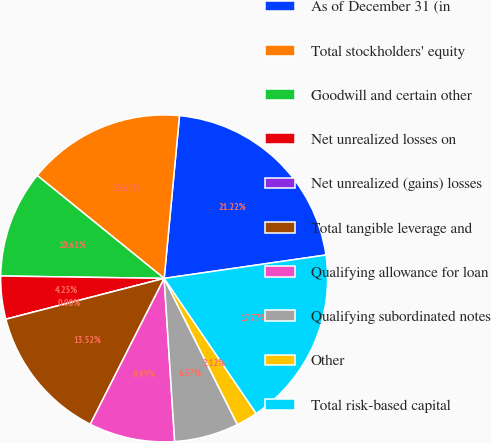<chart> <loc_0><loc_0><loc_500><loc_500><pie_chart><fcel>As of December 31 (in<fcel>Total stockholders' equity<fcel>Goodwill and certain other<fcel>Net unrealized losses on<fcel>Net unrealized (gains) losses<fcel>Total tangible leverage and<fcel>Qualifying allowance for loan<fcel>Qualifying subordinated notes<fcel>Other<fcel>Total risk-based capital<nl><fcel>21.22%<fcel>15.65%<fcel>10.61%<fcel>4.25%<fcel>0.0%<fcel>13.52%<fcel>8.49%<fcel>6.37%<fcel>2.12%<fcel>17.77%<nl></chart> 